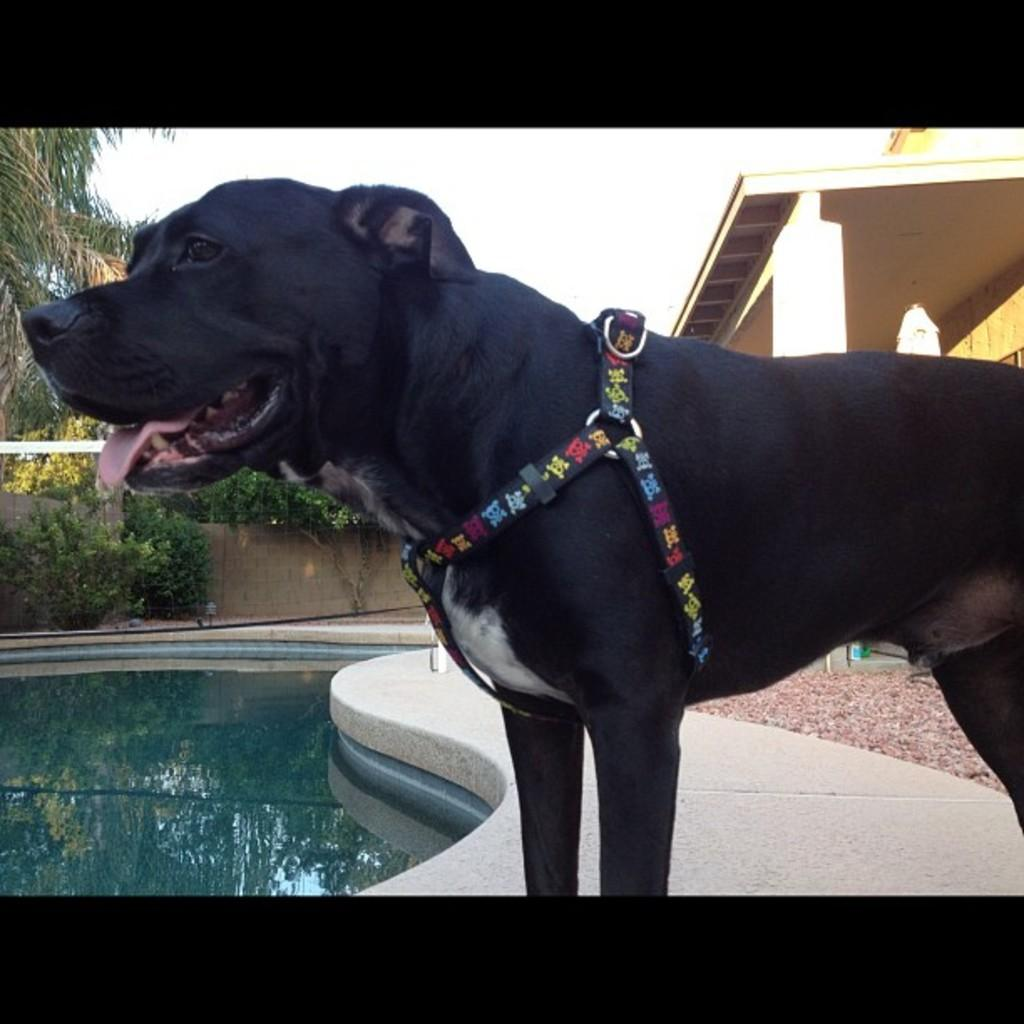What animal can be seen beside the swimming pool in the image? There is a dog standing beside the swimming pool in the image. What type of structure is visible in the image? There is a building visible in the image. What type of vegetation is present in the image? There are trees present in the image. What type of cap is the dog wearing in the image? There is no cap present on the dog in the image. How does the cork keep the swimming pool water from spilling out in the image? There is no cork present in the image, and the swimming pool is not depicted as spilling water. 